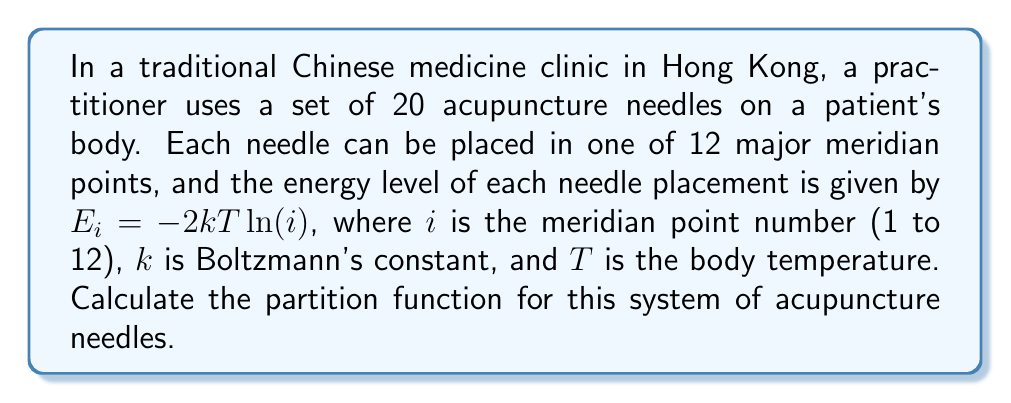Provide a solution to this math problem. To solve this problem, we'll follow these steps:

1) The partition function $Z$ for a system of independent particles is given by:

   $$Z = \sum_{\text{all states}} e^{-E/kT}$$

2) In this case, we have 20 independent needles, each with 12 possible states. The partition function for a single needle is:

   $$Z_1 = \sum_{i=1}^{12} e^{-E_i/kT}$$

3) Substituting the given energy level formula:

   $$Z_1 = \sum_{i=1}^{12} e^{-(-2kT\ln(i))/kT} = \sum_{i=1}^{12} e^{2\ln(i)} = \sum_{i=1}^{12} i^2$$

4) Calculate the sum:

   $$Z_1 = 1^2 + 2^2 + 3^2 + ... + 12^2 = 650$$

5) Since we have 20 independent needles, and each needle has the same partition function, the total partition function is:

   $$Z = (Z_1)^{20} = 650^{20}$$

6) Calculate the final result:

   $$Z = 650^{20} \approx 3.5552 \times 10^{58}$$
Answer: $Z \approx 3.5552 \times 10^{58}$ 